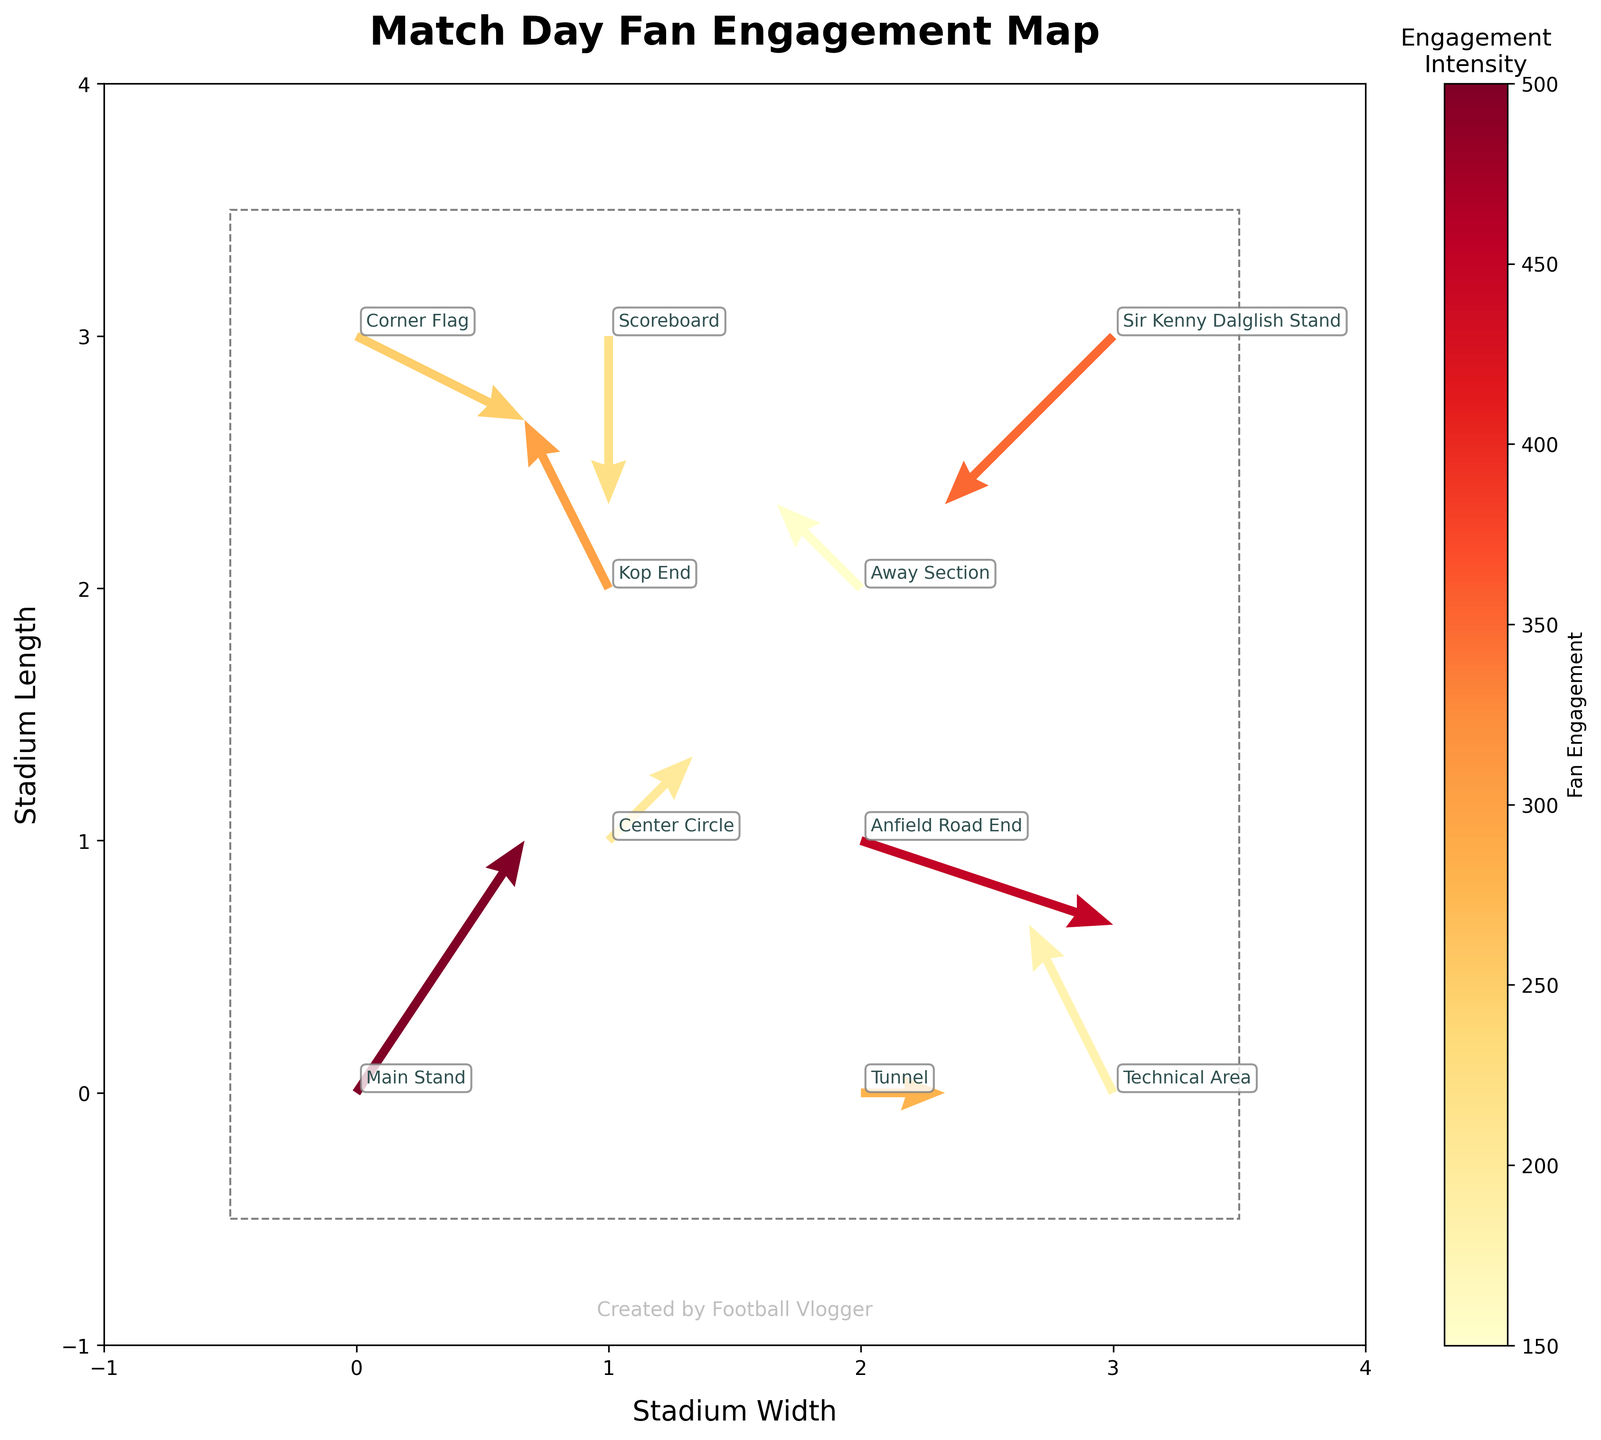How many data points are in the plot? You can count the number of quiver arrows in the figure. Here, there are 10 quiver arrows.
Answer: 10 What is the range of fan engagement shown in the color bar? The color bar on the right side of the plot indicates the range of fan engagement by the gradient colors. The range goes from 150 to 500.
Answer: 150 to 500 Which location has the highest fan engagement value? By looking at the color intensity associated with each quiver arrow, the darkest and most intense color corresponds to the Main Stand, indicating the highest engagement value of 500.
Answer: Main Stand Is the fan movement at the Sir Kenny Dalglish Stand predominantly positive or negative? Quiver arrows indicate the direction and magnitude of fan movement. The arrow at Sir Kenny Dalglish Stand points both leftward and downward, indicating a negative movement.
Answer: Negative Compare the fan engagement between the Tunnel and the Away Section. Which one is higher? Check the color intensity of the arrows at these locations. The Tunnel has a darker (more intense) color corresponding to a value of 280, while the Away Section has a lighter color corresponding to a value of 150. Therefore, the Tunnel has higher fan engagement.
Answer: Tunnel What is the average fan engagement across all locations? Calculate the average by summing up all fan engagement values and dividing by the number of data points: (500 + 300 + 450 + 350 + 200 + 150 + 250 + 180 + 220 + 280) / 10 = 288
Answer: 288 In which direction are fans moving the most dramatically in the stadium? By observing the lengths of the arrows, the longer arrows indicate more dramatic movements. The arrow at the Main Stand (2, 3) appears to be the longest, indicating the most significant movement in an upward and rightward direction.
Answer: Upward and rightward What is the fan engagement at the Kop End and how does it compare to Center Circle? Identify the fan engagement values: Kop End has 300 and Center Circle has 200. By comparing these values, Kop End has higher fan engagement than Center Circle.
Answer: Kop End with 300 is higher Which location shows a notable neutral fan movement, with both u and v components close to zero? Look for quiver arrows where the tail and head nearly overlap. The Scoreboard at (1, 3) shows a horizontal arrow mostly indicating neutral movement.
Answer: Scoreboard 